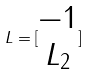Convert formula to latex. <formula><loc_0><loc_0><loc_500><loc_500>L = [ \begin{matrix} - 1 \\ L _ { 2 } \end{matrix} ]</formula> 